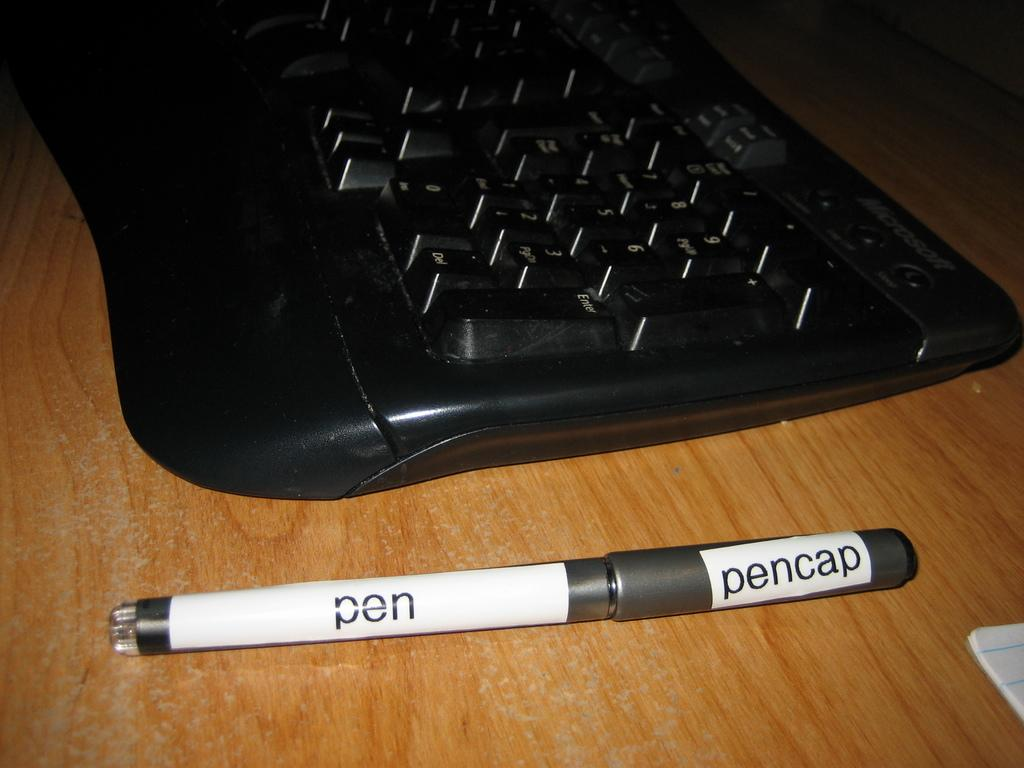<image>
Write a terse but informative summary of the picture. A pen sitting next to a keyboard is labeled with pen and pencap. 